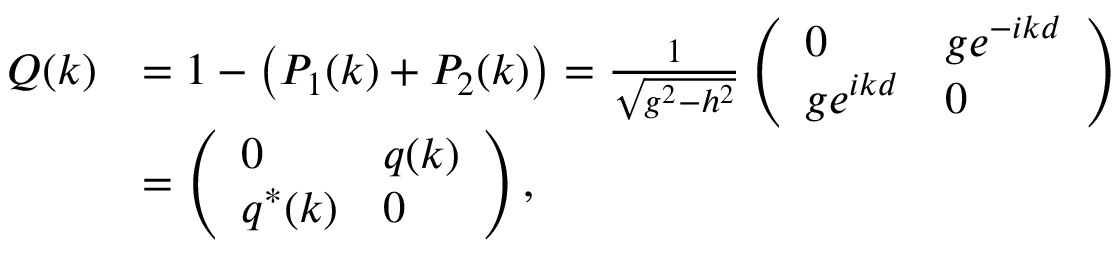<formula> <loc_0><loc_0><loc_500><loc_500>\begin{array} { r l } { Q ( k ) } & { = 1 - \left ( P _ { 1 } ( k ) + P _ { 2 } ( k ) \right ) = \frac { 1 } { \sqrt { g ^ { 2 } - h ^ { 2 } } } \left ( \begin{array} { l l } { 0 } & { g e ^ { - i k d } } \\ { g e ^ { i k d } } & { 0 } \end{array} \right ) } \\ & { = \left ( \begin{array} { l l } { 0 } & { q ( k ) } \\ { q ^ { * } ( k ) } & { 0 } \end{array} \right ) , } \end{array}</formula> 